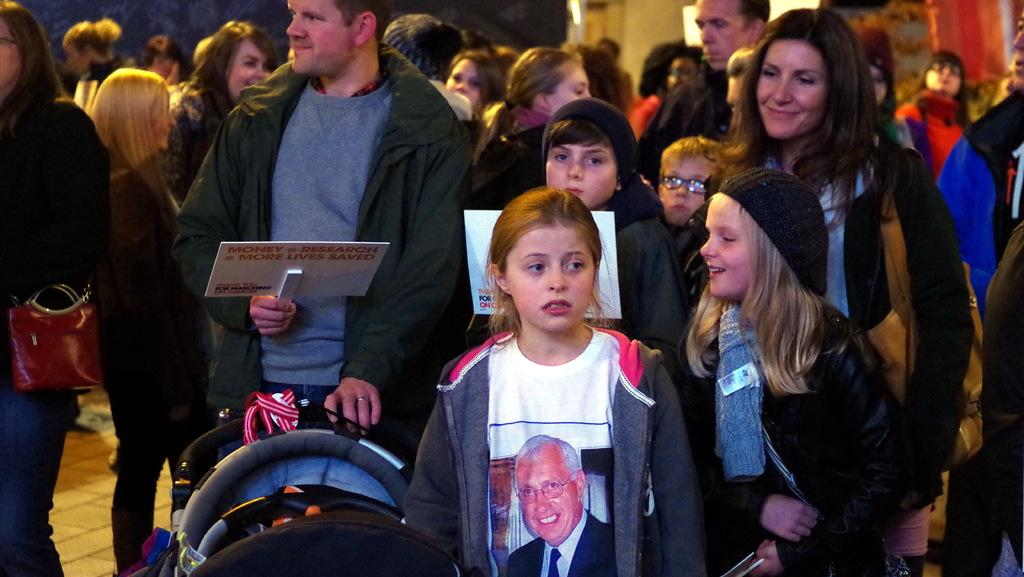What is the main subject of the picture? The main subject of the picture is a crowd. Can you describe any specific actions or objects being held by individuals in the crowd? Yes, two people are holding boards in the picture. What type of alarm is being sounded by the crowd in the image? There is no alarm present in the image; it features a crowd and two people holding boards. 